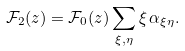Convert formula to latex. <formula><loc_0><loc_0><loc_500><loc_500>\mathcal { F } _ { 2 } ( z ) = \mathcal { F } _ { 0 } ( z ) \sum _ { \xi , \eta } \xi \, \alpha _ { \xi \eta } .</formula> 